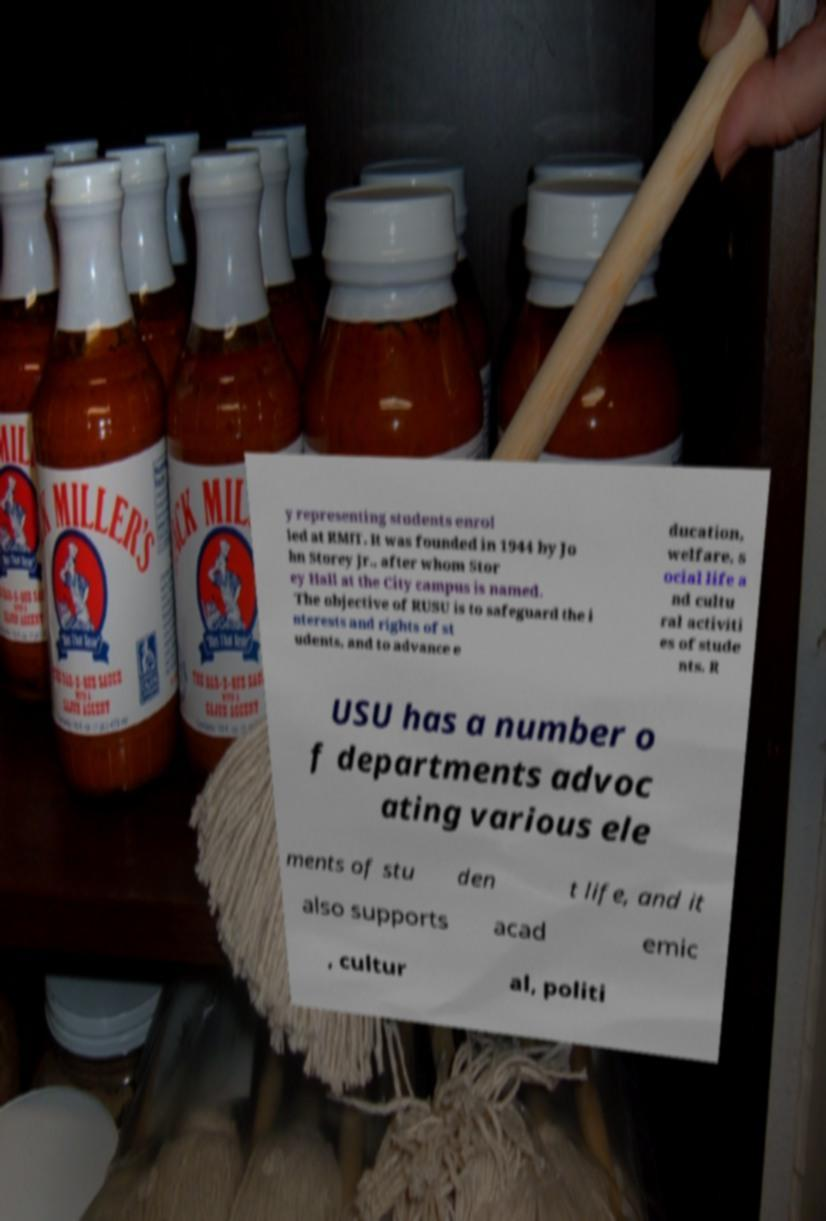Please identify and transcribe the text found in this image. y representing students enrol led at RMIT. It was founded in 1944 by Jo hn Storey Jr., after whom Stor ey Hall at the City campus is named. The objective of RUSU is to safeguard the i nterests and rights of st udents, and to advance e ducation, welfare, s ocial life a nd cultu ral activiti es of stude nts. R USU has a number o f departments advoc ating various ele ments of stu den t life, and it also supports acad emic , cultur al, politi 